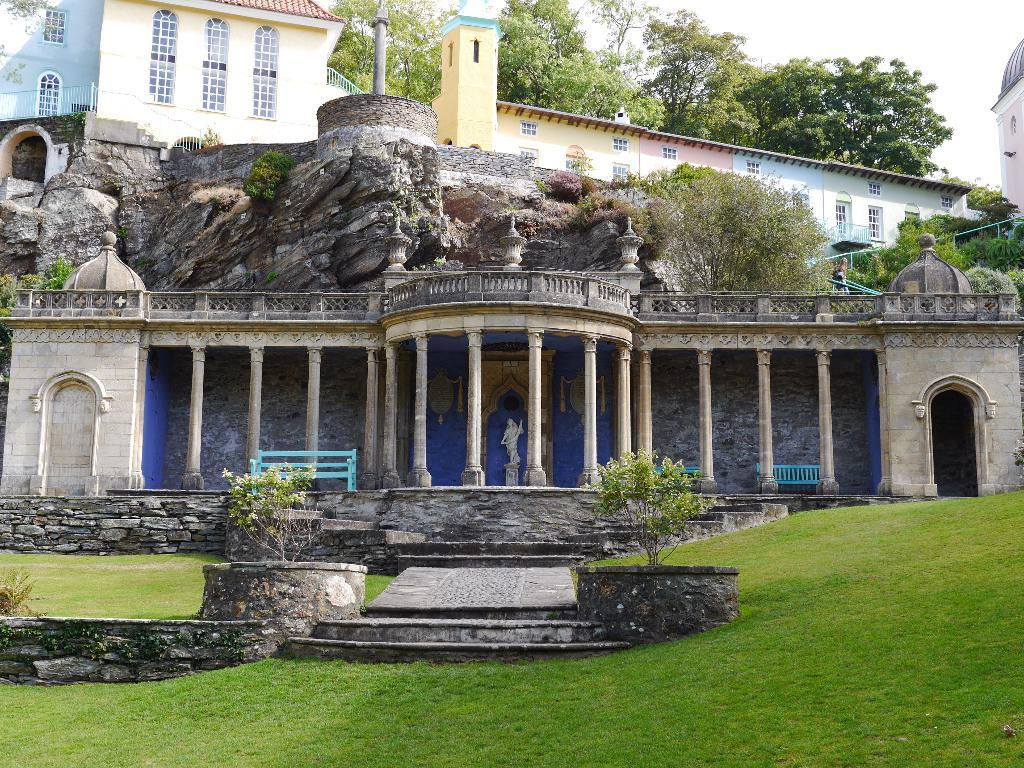What type of structures can be seen in the image? There are buildings in the image. What type of natural elements can be seen in the image? There are trees and plants in the image. What architectural feature is present in the image? There are stairs in the image. What type of seating is available in the image? There are benches in the image. What type of artwork is present in the image? There is a statue in the image. What type of safety feature is present in the image? There are railings in the image. What type of vertical structure is present in the image? There is a pole in the image. What part of the natural environment is visible in the image? The sky is visible at the top of the image, and the ground is visible at the bottom of the image. What direction is the map pointing towards in the image? There is no map present in the image. What type of transportation is used during the journey depicted in the image? There is no journey depicted in the image. What is the compass direction of the statue in the image? The image does not provide information about the compass direction of the statue. 